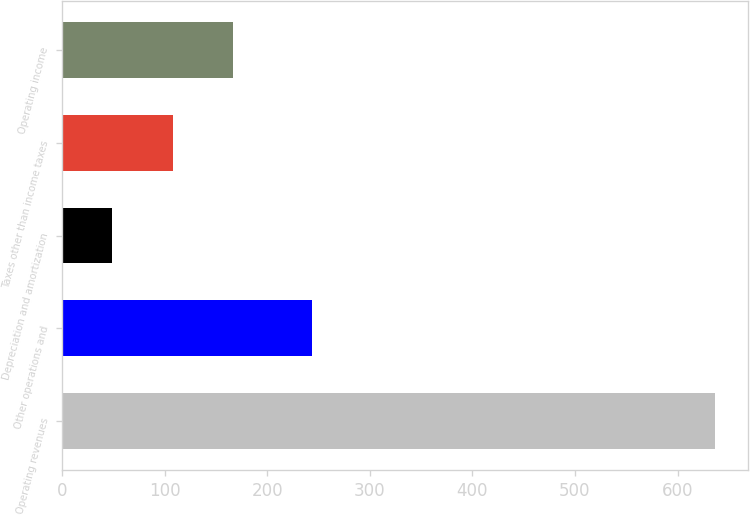Convert chart. <chart><loc_0><loc_0><loc_500><loc_500><bar_chart><fcel>Operating revenues<fcel>Other operations and<fcel>Depreciation and amortization<fcel>Taxes other than income taxes<fcel>Operating income<nl><fcel>637<fcel>244<fcel>49<fcel>107.8<fcel>166.6<nl></chart> 